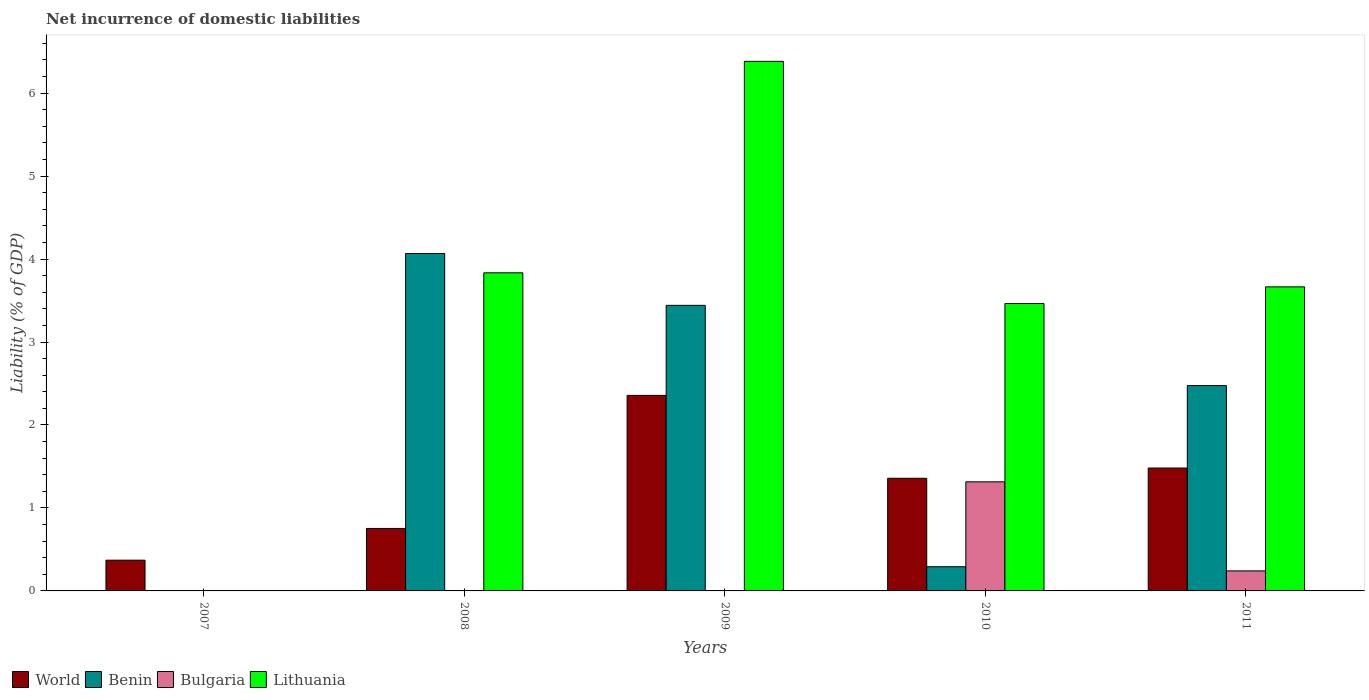How many different coloured bars are there?
Provide a succinct answer. 4. Are the number of bars per tick equal to the number of legend labels?
Your response must be concise. No. Are the number of bars on each tick of the X-axis equal?
Offer a terse response. No. How many bars are there on the 5th tick from the right?
Your answer should be very brief. 1. In how many cases, is the number of bars for a given year not equal to the number of legend labels?
Make the answer very short. 3. What is the net incurrence of domestic liabilities in Lithuania in 2009?
Offer a terse response. 6.38. Across all years, what is the maximum net incurrence of domestic liabilities in World?
Provide a succinct answer. 2.36. Across all years, what is the minimum net incurrence of domestic liabilities in Bulgaria?
Your answer should be compact. 0. What is the total net incurrence of domestic liabilities in Benin in the graph?
Your response must be concise. 10.28. What is the difference between the net incurrence of domestic liabilities in World in 2009 and that in 2010?
Your answer should be very brief. 1. What is the difference between the net incurrence of domestic liabilities in Benin in 2008 and the net incurrence of domestic liabilities in Lithuania in 2009?
Offer a terse response. -2.32. What is the average net incurrence of domestic liabilities in World per year?
Provide a succinct answer. 1.26. In the year 2010, what is the difference between the net incurrence of domestic liabilities in World and net incurrence of domestic liabilities in Benin?
Keep it short and to the point. 1.07. In how many years, is the net incurrence of domestic liabilities in Bulgaria greater than 5.6 %?
Provide a succinct answer. 0. What is the ratio of the net incurrence of domestic liabilities in World in 2008 to that in 2010?
Keep it short and to the point. 0.55. Is the net incurrence of domestic liabilities in World in 2009 less than that in 2010?
Make the answer very short. No. What is the difference between the highest and the second highest net incurrence of domestic liabilities in Lithuania?
Give a very brief answer. 2.55. What is the difference between the highest and the lowest net incurrence of domestic liabilities in World?
Make the answer very short. 1.99. Is it the case that in every year, the sum of the net incurrence of domestic liabilities in World and net incurrence of domestic liabilities in Benin is greater than the net incurrence of domestic liabilities in Lithuania?
Your answer should be very brief. No. How many bars are there?
Give a very brief answer. 15. How many years are there in the graph?
Your answer should be compact. 5. What is the difference between two consecutive major ticks on the Y-axis?
Keep it short and to the point. 1. Are the values on the major ticks of Y-axis written in scientific E-notation?
Offer a terse response. No. Does the graph contain grids?
Make the answer very short. No. Where does the legend appear in the graph?
Your answer should be very brief. Bottom left. How many legend labels are there?
Provide a short and direct response. 4. How are the legend labels stacked?
Your answer should be compact. Horizontal. What is the title of the graph?
Offer a terse response. Net incurrence of domestic liabilities. What is the label or title of the X-axis?
Your answer should be compact. Years. What is the label or title of the Y-axis?
Provide a succinct answer. Liability (% of GDP). What is the Liability (% of GDP) in World in 2007?
Your answer should be compact. 0.37. What is the Liability (% of GDP) of Benin in 2007?
Offer a terse response. 0. What is the Liability (% of GDP) of Bulgaria in 2007?
Give a very brief answer. 0. What is the Liability (% of GDP) in World in 2008?
Provide a short and direct response. 0.75. What is the Liability (% of GDP) in Benin in 2008?
Provide a succinct answer. 4.07. What is the Liability (% of GDP) in Lithuania in 2008?
Give a very brief answer. 3.83. What is the Liability (% of GDP) in World in 2009?
Give a very brief answer. 2.36. What is the Liability (% of GDP) of Benin in 2009?
Your response must be concise. 3.44. What is the Liability (% of GDP) of Lithuania in 2009?
Make the answer very short. 6.38. What is the Liability (% of GDP) in World in 2010?
Your answer should be compact. 1.36. What is the Liability (% of GDP) of Benin in 2010?
Your answer should be compact. 0.29. What is the Liability (% of GDP) of Bulgaria in 2010?
Provide a short and direct response. 1.31. What is the Liability (% of GDP) in Lithuania in 2010?
Offer a very short reply. 3.46. What is the Liability (% of GDP) of World in 2011?
Offer a terse response. 1.48. What is the Liability (% of GDP) in Benin in 2011?
Ensure brevity in your answer.  2.47. What is the Liability (% of GDP) in Bulgaria in 2011?
Make the answer very short. 0.24. What is the Liability (% of GDP) in Lithuania in 2011?
Ensure brevity in your answer.  3.66. Across all years, what is the maximum Liability (% of GDP) in World?
Your answer should be very brief. 2.36. Across all years, what is the maximum Liability (% of GDP) of Benin?
Make the answer very short. 4.07. Across all years, what is the maximum Liability (% of GDP) in Bulgaria?
Give a very brief answer. 1.31. Across all years, what is the maximum Liability (% of GDP) of Lithuania?
Your response must be concise. 6.38. Across all years, what is the minimum Liability (% of GDP) of World?
Give a very brief answer. 0.37. Across all years, what is the minimum Liability (% of GDP) in Benin?
Your response must be concise. 0. Across all years, what is the minimum Liability (% of GDP) of Lithuania?
Make the answer very short. 0. What is the total Liability (% of GDP) of World in the graph?
Your answer should be compact. 6.32. What is the total Liability (% of GDP) in Benin in the graph?
Make the answer very short. 10.28. What is the total Liability (% of GDP) in Bulgaria in the graph?
Provide a short and direct response. 1.56. What is the total Liability (% of GDP) in Lithuania in the graph?
Provide a succinct answer. 17.35. What is the difference between the Liability (% of GDP) in World in 2007 and that in 2008?
Your answer should be compact. -0.38. What is the difference between the Liability (% of GDP) of World in 2007 and that in 2009?
Provide a succinct answer. -1.99. What is the difference between the Liability (% of GDP) of World in 2007 and that in 2010?
Your response must be concise. -0.99. What is the difference between the Liability (% of GDP) of World in 2007 and that in 2011?
Give a very brief answer. -1.11. What is the difference between the Liability (% of GDP) of World in 2008 and that in 2009?
Offer a very short reply. -1.6. What is the difference between the Liability (% of GDP) in Benin in 2008 and that in 2009?
Ensure brevity in your answer.  0.63. What is the difference between the Liability (% of GDP) of Lithuania in 2008 and that in 2009?
Provide a succinct answer. -2.55. What is the difference between the Liability (% of GDP) of World in 2008 and that in 2010?
Your response must be concise. -0.6. What is the difference between the Liability (% of GDP) of Benin in 2008 and that in 2010?
Ensure brevity in your answer.  3.78. What is the difference between the Liability (% of GDP) in Lithuania in 2008 and that in 2010?
Ensure brevity in your answer.  0.37. What is the difference between the Liability (% of GDP) in World in 2008 and that in 2011?
Ensure brevity in your answer.  -0.73. What is the difference between the Liability (% of GDP) in Benin in 2008 and that in 2011?
Offer a very short reply. 1.59. What is the difference between the Liability (% of GDP) in Lithuania in 2008 and that in 2011?
Provide a succinct answer. 0.17. What is the difference between the Liability (% of GDP) of World in 2009 and that in 2010?
Provide a short and direct response. 1. What is the difference between the Liability (% of GDP) of Benin in 2009 and that in 2010?
Provide a succinct answer. 3.15. What is the difference between the Liability (% of GDP) of Lithuania in 2009 and that in 2010?
Keep it short and to the point. 2.92. What is the difference between the Liability (% of GDP) in World in 2009 and that in 2011?
Provide a short and direct response. 0.88. What is the difference between the Liability (% of GDP) in Lithuania in 2009 and that in 2011?
Offer a very short reply. 2.72. What is the difference between the Liability (% of GDP) of World in 2010 and that in 2011?
Give a very brief answer. -0.12. What is the difference between the Liability (% of GDP) of Benin in 2010 and that in 2011?
Provide a short and direct response. -2.18. What is the difference between the Liability (% of GDP) of Bulgaria in 2010 and that in 2011?
Provide a succinct answer. 1.07. What is the difference between the Liability (% of GDP) in Lithuania in 2010 and that in 2011?
Offer a very short reply. -0.2. What is the difference between the Liability (% of GDP) of World in 2007 and the Liability (% of GDP) of Benin in 2008?
Keep it short and to the point. -3.7. What is the difference between the Liability (% of GDP) of World in 2007 and the Liability (% of GDP) of Lithuania in 2008?
Your answer should be very brief. -3.46. What is the difference between the Liability (% of GDP) of World in 2007 and the Liability (% of GDP) of Benin in 2009?
Offer a very short reply. -3.07. What is the difference between the Liability (% of GDP) of World in 2007 and the Liability (% of GDP) of Lithuania in 2009?
Give a very brief answer. -6.01. What is the difference between the Liability (% of GDP) of World in 2007 and the Liability (% of GDP) of Benin in 2010?
Ensure brevity in your answer.  0.08. What is the difference between the Liability (% of GDP) in World in 2007 and the Liability (% of GDP) in Bulgaria in 2010?
Make the answer very short. -0.94. What is the difference between the Liability (% of GDP) in World in 2007 and the Liability (% of GDP) in Lithuania in 2010?
Keep it short and to the point. -3.09. What is the difference between the Liability (% of GDP) of World in 2007 and the Liability (% of GDP) of Benin in 2011?
Your answer should be compact. -2.1. What is the difference between the Liability (% of GDP) in World in 2007 and the Liability (% of GDP) in Bulgaria in 2011?
Keep it short and to the point. 0.13. What is the difference between the Liability (% of GDP) of World in 2007 and the Liability (% of GDP) of Lithuania in 2011?
Keep it short and to the point. -3.29. What is the difference between the Liability (% of GDP) of World in 2008 and the Liability (% of GDP) of Benin in 2009?
Ensure brevity in your answer.  -2.69. What is the difference between the Liability (% of GDP) of World in 2008 and the Liability (% of GDP) of Lithuania in 2009?
Your answer should be very brief. -5.63. What is the difference between the Liability (% of GDP) of Benin in 2008 and the Liability (% of GDP) of Lithuania in 2009?
Give a very brief answer. -2.32. What is the difference between the Liability (% of GDP) in World in 2008 and the Liability (% of GDP) in Benin in 2010?
Offer a terse response. 0.46. What is the difference between the Liability (% of GDP) in World in 2008 and the Liability (% of GDP) in Bulgaria in 2010?
Provide a short and direct response. -0.56. What is the difference between the Liability (% of GDP) of World in 2008 and the Liability (% of GDP) of Lithuania in 2010?
Offer a very short reply. -2.71. What is the difference between the Liability (% of GDP) in Benin in 2008 and the Liability (% of GDP) in Bulgaria in 2010?
Your answer should be very brief. 2.75. What is the difference between the Liability (% of GDP) of Benin in 2008 and the Liability (% of GDP) of Lithuania in 2010?
Your response must be concise. 0.6. What is the difference between the Liability (% of GDP) in World in 2008 and the Liability (% of GDP) in Benin in 2011?
Offer a terse response. -1.72. What is the difference between the Liability (% of GDP) in World in 2008 and the Liability (% of GDP) in Bulgaria in 2011?
Offer a terse response. 0.51. What is the difference between the Liability (% of GDP) of World in 2008 and the Liability (% of GDP) of Lithuania in 2011?
Offer a very short reply. -2.91. What is the difference between the Liability (% of GDP) in Benin in 2008 and the Liability (% of GDP) in Bulgaria in 2011?
Make the answer very short. 3.83. What is the difference between the Liability (% of GDP) in Benin in 2008 and the Liability (% of GDP) in Lithuania in 2011?
Your answer should be very brief. 0.4. What is the difference between the Liability (% of GDP) of World in 2009 and the Liability (% of GDP) of Benin in 2010?
Your response must be concise. 2.07. What is the difference between the Liability (% of GDP) in World in 2009 and the Liability (% of GDP) in Bulgaria in 2010?
Your answer should be very brief. 1.04. What is the difference between the Liability (% of GDP) in World in 2009 and the Liability (% of GDP) in Lithuania in 2010?
Your response must be concise. -1.11. What is the difference between the Liability (% of GDP) of Benin in 2009 and the Liability (% of GDP) of Bulgaria in 2010?
Your answer should be very brief. 2.13. What is the difference between the Liability (% of GDP) of Benin in 2009 and the Liability (% of GDP) of Lithuania in 2010?
Your response must be concise. -0.02. What is the difference between the Liability (% of GDP) in World in 2009 and the Liability (% of GDP) in Benin in 2011?
Offer a very short reply. -0.12. What is the difference between the Liability (% of GDP) in World in 2009 and the Liability (% of GDP) in Bulgaria in 2011?
Keep it short and to the point. 2.12. What is the difference between the Liability (% of GDP) in World in 2009 and the Liability (% of GDP) in Lithuania in 2011?
Your response must be concise. -1.31. What is the difference between the Liability (% of GDP) in Benin in 2009 and the Liability (% of GDP) in Bulgaria in 2011?
Your response must be concise. 3.2. What is the difference between the Liability (% of GDP) in Benin in 2009 and the Liability (% of GDP) in Lithuania in 2011?
Ensure brevity in your answer.  -0.22. What is the difference between the Liability (% of GDP) in World in 2010 and the Liability (% of GDP) in Benin in 2011?
Give a very brief answer. -1.12. What is the difference between the Liability (% of GDP) in World in 2010 and the Liability (% of GDP) in Bulgaria in 2011?
Your response must be concise. 1.12. What is the difference between the Liability (% of GDP) in World in 2010 and the Liability (% of GDP) in Lithuania in 2011?
Offer a very short reply. -2.31. What is the difference between the Liability (% of GDP) of Benin in 2010 and the Liability (% of GDP) of Bulgaria in 2011?
Your answer should be very brief. 0.05. What is the difference between the Liability (% of GDP) of Benin in 2010 and the Liability (% of GDP) of Lithuania in 2011?
Make the answer very short. -3.37. What is the difference between the Liability (% of GDP) of Bulgaria in 2010 and the Liability (% of GDP) of Lithuania in 2011?
Provide a short and direct response. -2.35. What is the average Liability (% of GDP) in World per year?
Keep it short and to the point. 1.26. What is the average Liability (% of GDP) in Benin per year?
Your answer should be compact. 2.06. What is the average Liability (% of GDP) of Bulgaria per year?
Offer a terse response. 0.31. What is the average Liability (% of GDP) of Lithuania per year?
Offer a very short reply. 3.47. In the year 2008, what is the difference between the Liability (% of GDP) in World and Liability (% of GDP) in Benin?
Provide a succinct answer. -3.31. In the year 2008, what is the difference between the Liability (% of GDP) in World and Liability (% of GDP) in Lithuania?
Keep it short and to the point. -3.08. In the year 2008, what is the difference between the Liability (% of GDP) in Benin and Liability (% of GDP) in Lithuania?
Your response must be concise. 0.23. In the year 2009, what is the difference between the Liability (% of GDP) of World and Liability (% of GDP) of Benin?
Offer a very short reply. -1.09. In the year 2009, what is the difference between the Liability (% of GDP) in World and Liability (% of GDP) in Lithuania?
Provide a short and direct response. -4.03. In the year 2009, what is the difference between the Liability (% of GDP) of Benin and Liability (% of GDP) of Lithuania?
Keep it short and to the point. -2.94. In the year 2010, what is the difference between the Liability (% of GDP) in World and Liability (% of GDP) in Benin?
Give a very brief answer. 1.07. In the year 2010, what is the difference between the Liability (% of GDP) of World and Liability (% of GDP) of Bulgaria?
Your answer should be very brief. 0.04. In the year 2010, what is the difference between the Liability (% of GDP) of World and Liability (% of GDP) of Lithuania?
Give a very brief answer. -2.11. In the year 2010, what is the difference between the Liability (% of GDP) of Benin and Liability (% of GDP) of Bulgaria?
Offer a very short reply. -1.02. In the year 2010, what is the difference between the Liability (% of GDP) of Benin and Liability (% of GDP) of Lithuania?
Your response must be concise. -3.17. In the year 2010, what is the difference between the Liability (% of GDP) of Bulgaria and Liability (% of GDP) of Lithuania?
Ensure brevity in your answer.  -2.15. In the year 2011, what is the difference between the Liability (% of GDP) of World and Liability (% of GDP) of Benin?
Offer a very short reply. -0.99. In the year 2011, what is the difference between the Liability (% of GDP) of World and Liability (% of GDP) of Bulgaria?
Your answer should be compact. 1.24. In the year 2011, what is the difference between the Liability (% of GDP) in World and Liability (% of GDP) in Lithuania?
Ensure brevity in your answer.  -2.18. In the year 2011, what is the difference between the Liability (% of GDP) in Benin and Liability (% of GDP) in Bulgaria?
Give a very brief answer. 2.23. In the year 2011, what is the difference between the Liability (% of GDP) of Benin and Liability (% of GDP) of Lithuania?
Provide a short and direct response. -1.19. In the year 2011, what is the difference between the Liability (% of GDP) of Bulgaria and Liability (% of GDP) of Lithuania?
Give a very brief answer. -3.42. What is the ratio of the Liability (% of GDP) of World in 2007 to that in 2008?
Your answer should be compact. 0.49. What is the ratio of the Liability (% of GDP) in World in 2007 to that in 2009?
Your response must be concise. 0.16. What is the ratio of the Liability (% of GDP) in World in 2007 to that in 2010?
Offer a terse response. 0.27. What is the ratio of the Liability (% of GDP) in World in 2007 to that in 2011?
Provide a short and direct response. 0.25. What is the ratio of the Liability (% of GDP) in World in 2008 to that in 2009?
Offer a terse response. 0.32. What is the ratio of the Liability (% of GDP) in Benin in 2008 to that in 2009?
Make the answer very short. 1.18. What is the ratio of the Liability (% of GDP) in Lithuania in 2008 to that in 2009?
Your answer should be very brief. 0.6. What is the ratio of the Liability (% of GDP) in World in 2008 to that in 2010?
Ensure brevity in your answer.  0.55. What is the ratio of the Liability (% of GDP) of Benin in 2008 to that in 2010?
Your answer should be very brief. 13.97. What is the ratio of the Liability (% of GDP) of Lithuania in 2008 to that in 2010?
Provide a short and direct response. 1.11. What is the ratio of the Liability (% of GDP) in World in 2008 to that in 2011?
Make the answer very short. 0.51. What is the ratio of the Liability (% of GDP) in Benin in 2008 to that in 2011?
Your response must be concise. 1.64. What is the ratio of the Liability (% of GDP) of Lithuania in 2008 to that in 2011?
Make the answer very short. 1.05. What is the ratio of the Liability (% of GDP) in World in 2009 to that in 2010?
Your answer should be very brief. 1.74. What is the ratio of the Liability (% of GDP) in Benin in 2009 to that in 2010?
Offer a very short reply. 11.82. What is the ratio of the Liability (% of GDP) in Lithuania in 2009 to that in 2010?
Your answer should be very brief. 1.84. What is the ratio of the Liability (% of GDP) in World in 2009 to that in 2011?
Keep it short and to the point. 1.59. What is the ratio of the Liability (% of GDP) in Benin in 2009 to that in 2011?
Keep it short and to the point. 1.39. What is the ratio of the Liability (% of GDP) in Lithuania in 2009 to that in 2011?
Your response must be concise. 1.74. What is the ratio of the Liability (% of GDP) in Benin in 2010 to that in 2011?
Offer a terse response. 0.12. What is the ratio of the Liability (% of GDP) in Bulgaria in 2010 to that in 2011?
Provide a short and direct response. 5.45. What is the ratio of the Liability (% of GDP) of Lithuania in 2010 to that in 2011?
Keep it short and to the point. 0.95. What is the difference between the highest and the second highest Liability (% of GDP) in World?
Your answer should be very brief. 0.88. What is the difference between the highest and the second highest Liability (% of GDP) in Benin?
Keep it short and to the point. 0.63. What is the difference between the highest and the second highest Liability (% of GDP) of Lithuania?
Offer a very short reply. 2.55. What is the difference between the highest and the lowest Liability (% of GDP) of World?
Keep it short and to the point. 1.99. What is the difference between the highest and the lowest Liability (% of GDP) in Benin?
Provide a succinct answer. 4.07. What is the difference between the highest and the lowest Liability (% of GDP) in Bulgaria?
Provide a short and direct response. 1.31. What is the difference between the highest and the lowest Liability (% of GDP) in Lithuania?
Provide a short and direct response. 6.38. 